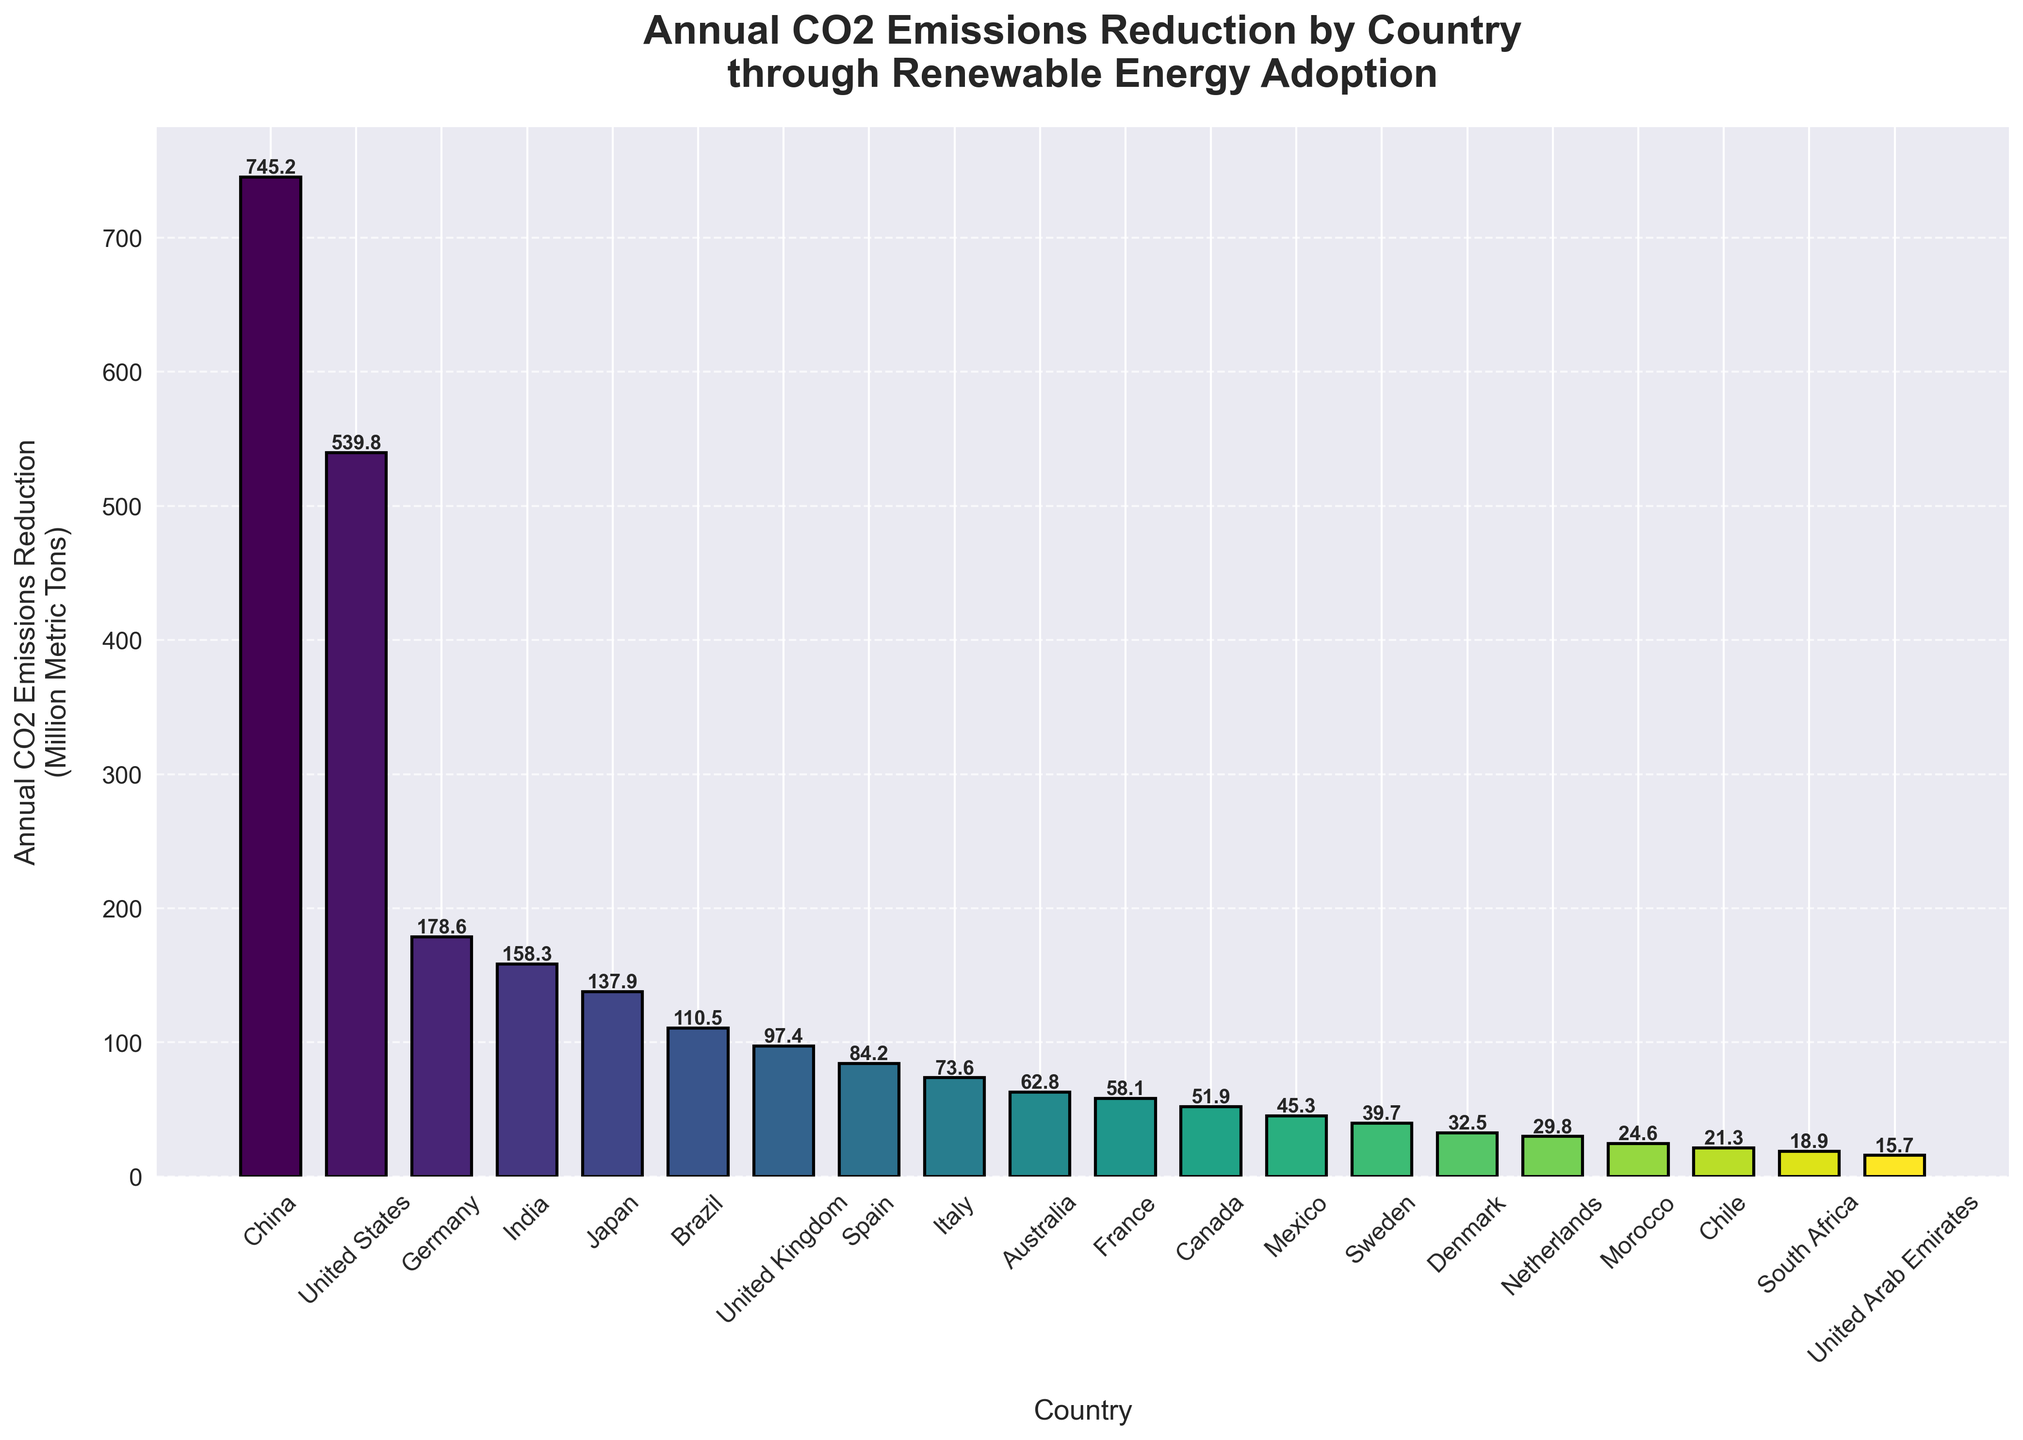Which country has the highest annual CO2 emissions reduction through renewable energy adoption? China has the tallest bar indicating the highest annual CO2 emissions reduction, which is 745.2 million metric tons.
Answer: China Which country has the lowest annual CO2 emissions reduction through renewable energy adoption? The United Arab Emirates has the smallest bar, indicating the lowest annual CO2 emissions reduction, which is 15.7 million metric tons.
Answer: United Arab Emirates Which two countries together contribute nearly equal to the United States' annual CO2 emissions reduction through renewable energy adoption? Adding the CO2 emissions reduction of Germany (178.6) and India (158.3) equals 336.9 million metric tons, which is much less than the United States' reduction of 539.8. Adding Japan (137.9) along with Germany (178.6) equals 316.5, similarly less. The combined reductions of Germany, India, Japan, and Brazil (110.5) together total 585.3 which is closest to the United States.
Answer: Germany and India How much more CO2 does China reduce annually compared to India? Subtract the annual CO2 reduction of India (158.3) from China's reduction (745.2), resulting in 745.2 - 158.3 = 586.9 million metric tons.
Answer: 586.9 Which country emits nearly double the amount of CO2 reduction compared to Brazil? The country should have CO2 reductions close to 2 * 110.5. Japan with 137.9 comes close but it's not double. India with 158.3 is still not double. Germany at 178.6 is less than double, but the United States with 539.8 is more than double.
Answer: United States By how much do the CO2 reductions in France and Canada collectively fall short of Italy's reductions? France's reduction (58.1) plus Canada's reduction (51.9) equals 110.0 million metric tons. Italy's reduction is 73.6 million metric tons. Subtract Italy's reduction from the collective amount: 110.0 - 73.6 = 36.4. Compendiously, it doesn't fall short but exceeds. Hence, Italy alone falls short of France and Canada's collective reduction by 36.4.
Answer: 36.4 Which countries have bars with nearly the same heights indicating similar CO2 emission reductions, and what are their values? Italy and Australia have nearly similar bar heights indicating similar CO2 reductions: Italy (73.6) and Australia (62.8). Visual inspection shows these two bars are closest in height.
Answer: Italy and Australia How many countries have an annual CO2 emissions reduction greater than 100 million metric tons? The countries are China, United States, Germany, India, Japan, and Brazil. This sums up to 6 countries.
Answer: 6 Which country shows a reduction less than 25 million metric tons and more than 20 million metric tons? Chile falls into this range with 21.3 million metric tons, which the bar visually represents as right between 20 and 25.
Answer: Chile 